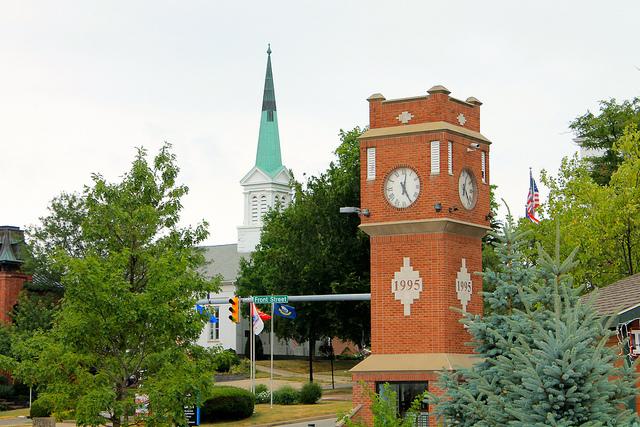How many clocks are on the building?
Be succinct. 4. What is the name of that road?
Short answer required. Don't know. What is the number of the building?
Write a very short answer. 1995. 